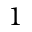Convert formula to latex. <formula><loc_0><loc_0><loc_500><loc_500>1</formula> 